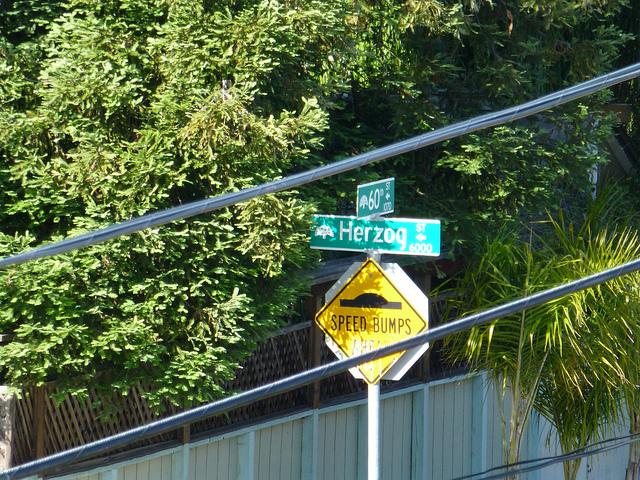What color is the tree?
Keep it brief. Green. Which way is 6010 Herzog Street?
Concise answer only. Left. What are ahead?
Answer briefly. Speed bumps. 